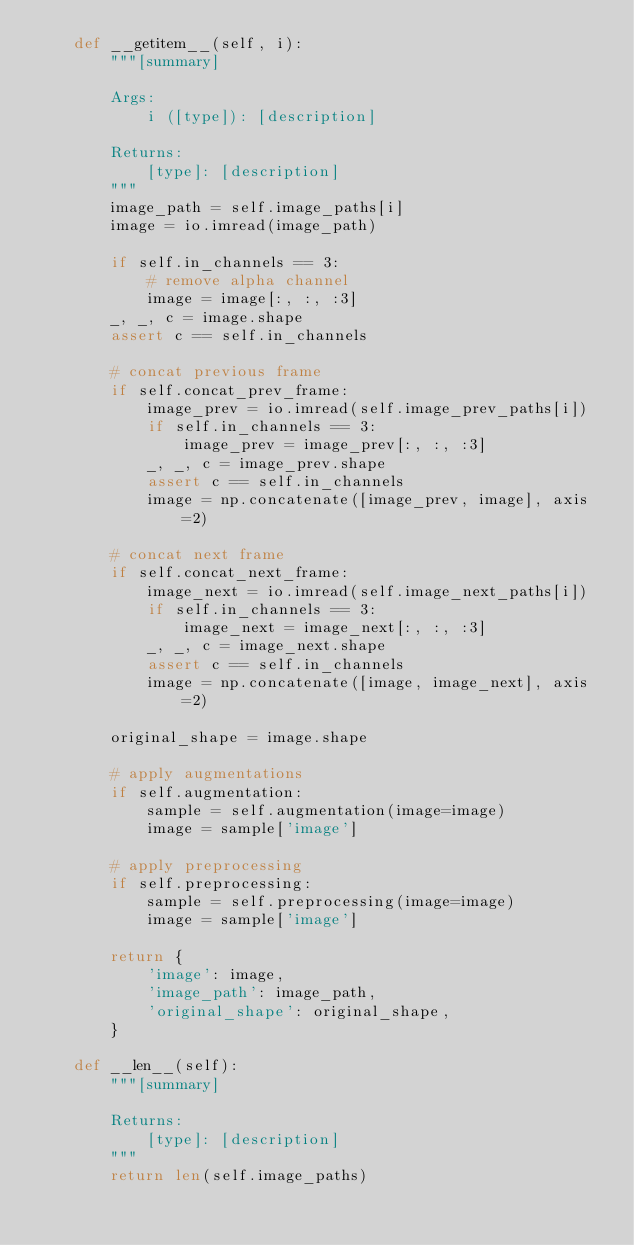<code> <loc_0><loc_0><loc_500><loc_500><_Python_>    def __getitem__(self, i):
        """[summary]

        Args:
            i ([type]): [description]

        Returns:
            [type]: [description]
        """
        image_path = self.image_paths[i]
        image = io.imread(image_path)

        if self.in_channels == 3:
            # remove alpha channel
            image = image[:, :, :3]
        _, _, c = image.shape
        assert c == self.in_channels

        # concat previous frame
        if self.concat_prev_frame:
            image_prev = io.imread(self.image_prev_paths[i])
            if self.in_channels == 3:
                image_prev = image_prev[:, :, :3]
            _, _, c = image_prev.shape
            assert c == self.in_channels
            image = np.concatenate([image_prev, image], axis=2)

        # concat next frame
        if self.concat_next_frame:
            image_next = io.imread(self.image_next_paths[i])
            if self.in_channels == 3:
                image_next = image_next[:, :, :3]
            _, _, c = image_next.shape
            assert c == self.in_channels
            image = np.concatenate([image, image_next], axis=2)

        original_shape = image.shape

        # apply augmentations
        if self.augmentation:
            sample = self.augmentation(image=image)
            image = sample['image']

        # apply preprocessing
        if self.preprocessing:
            sample = self.preprocessing(image=image)
            image = sample['image']

        return {
            'image': image,
            'image_path': image_path,
            'original_shape': original_shape,
        }

    def __len__(self):
        """[summary]

        Returns:
            [type]: [description]
        """
        return len(self.image_paths)
</code> 